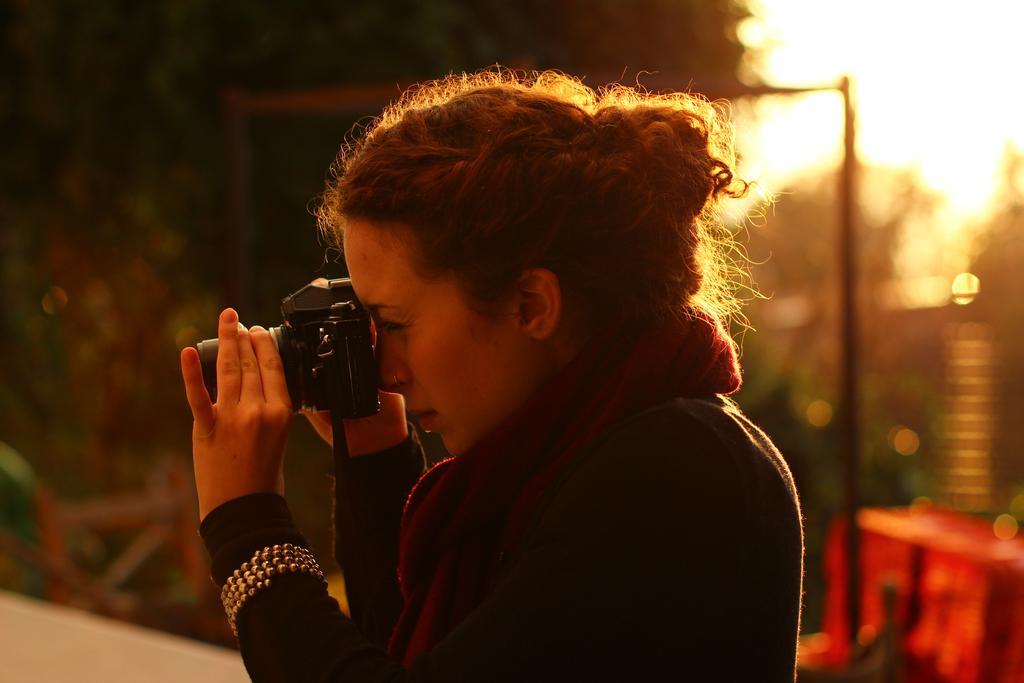In one or two sentences, can you explain what this image depicts? In this picture one lady is clicking picture. She is wearing black dress and red scarf. In the background there are trees. 